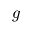<formula> <loc_0><loc_0><loc_500><loc_500>g</formula> 